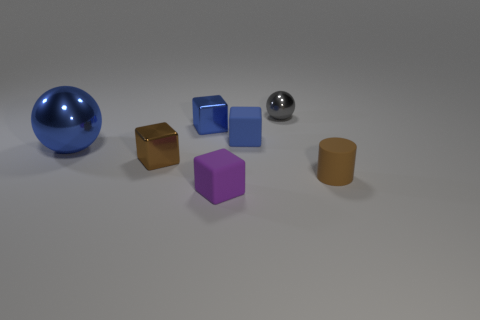Is there any pattern in how the objects are arranged? There doesn't appear to be a deliberate pattern; the objects are scattered randomly across the surface. However, they are positioned in a way that demonstrates a contrast in colors, sizes, and shapes, emphasizing their diversity. Do the objects seem to interact with each other in any way? While the objects are not physically interacting, there is an interplay of light and shadow that connects them visually. The reflective surfaces of the glossy and metallic objects create reflections and highlights that affect the appearance of nearby matte objects. 